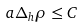Convert formula to latex. <formula><loc_0><loc_0><loc_500><loc_500>a \Delta _ { h } \rho \leq C</formula> 